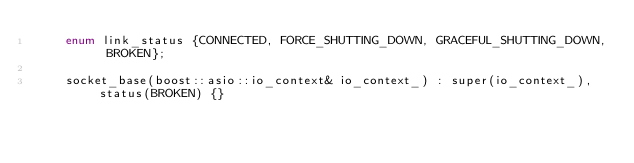<code> <loc_0><loc_0><loc_500><loc_500><_C_>	enum link_status {CONNECTED, FORCE_SHUTTING_DOWN, GRACEFUL_SHUTTING_DOWN, BROKEN};

	socket_base(boost::asio::io_context& io_context_) : super(io_context_), status(BROKEN) {}</code> 